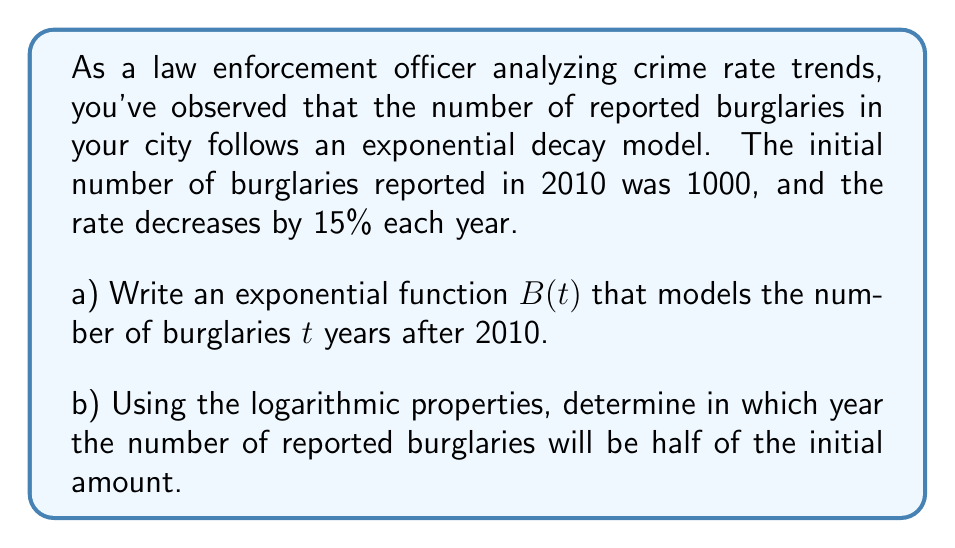Show me your answer to this math problem. a) To write the exponential function:
   - Initial value: $B(0) = 1000$
   - Decay rate: 15% = 0.15
   - Growth factor: $1 - 0.15 = 0.85$

   The exponential function is:
   $$ B(t) = 1000 \cdot (0.85)^t $$

b) To find when the number of burglaries will be half:
   1) Set up the equation:
      $$ 1000 \cdot (0.85)^t = 500 $$

   2) Divide both sides by 1000:
      $$ (0.85)^t = 0.5 $$

   3) Take the natural logarithm of both sides:
      $$ \ln(0.85^t) = \ln(0.5) $$

   4) Use the logarithm property $\ln(a^b) = b\ln(a)$:
      $$ t \cdot \ln(0.85) = \ln(0.5) $$

   5) Solve for $t$:
      $$ t = \frac{\ln(0.5)}{\ln(0.85)} $$

   6) Calculate:
      $$ t \approx 4.27 \text{ years} $$

   7) Since we're dealing with whole years, round up to 5 years.

   The number of burglaries will be half the initial amount in 2015 (5 years after 2010).
Answer: a) $B(t) = 1000 \cdot (0.85)^t$
b) The number of reported burglaries will be half of the initial amount in 2015, 5 years after 2010. 